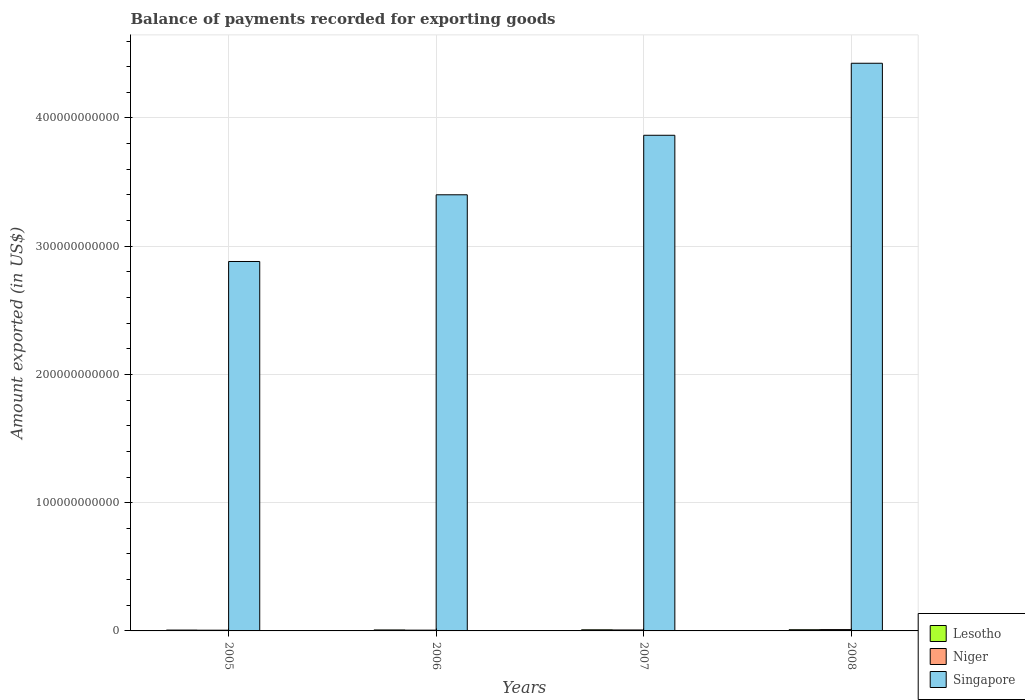Are the number of bars per tick equal to the number of legend labels?
Ensure brevity in your answer.  Yes. How many bars are there on the 1st tick from the left?
Ensure brevity in your answer.  3. In how many cases, is the number of bars for a given year not equal to the number of legend labels?
Offer a terse response. 0. What is the amount exported in Singapore in 2005?
Provide a short and direct response. 2.88e+11. Across all years, what is the maximum amount exported in Singapore?
Your response must be concise. 4.43e+11. Across all years, what is the minimum amount exported in Niger?
Your response must be concise. 5.65e+08. In which year was the amount exported in Niger minimum?
Your answer should be very brief. 2005. What is the total amount exported in Singapore in the graph?
Offer a very short reply. 1.46e+12. What is the difference between the amount exported in Niger in 2005 and that in 2008?
Your answer should be very brief. -4.78e+08. What is the difference between the amount exported in Lesotho in 2007 and the amount exported in Singapore in 2008?
Offer a terse response. -4.42e+11. What is the average amount exported in Singapore per year?
Offer a terse response. 3.64e+11. In the year 2005, what is the difference between the amount exported in Niger and amount exported in Singapore?
Your response must be concise. -2.88e+11. In how many years, is the amount exported in Lesotho greater than 200000000000 US$?
Make the answer very short. 0. What is the ratio of the amount exported in Lesotho in 2006 to that in 2008?
Give a very brief answer. 0.81. Is the difference between the amount exported in Niger in 2006 and 2008 greater than the difference between the amount exported in Singapore in 2006 and 2008?
Make the answer very short. Yes. What is the difference between the highest and the second highest amount exported in Niger?
Provide a short and direct response. 2.96e+08. What is the difference between the highest and the lowest amount exported in Lesotho?
Keep it short and to the point. 2.64e+08. Is the sum of the amount exported in Singapore in 2006 and 2008 greater than the maximum amount exported in Niger across all years?
Your answer should be very brief. Yes. What does the 2nd bar from the left in 2007 represents?
Offer a terse response. Niger. What does the 2nd bar from the right in 2007 represents?
Your answer should be compact. Niger. Is it the case that in every year, the sum of the amount exported in Niger and amount exported in Lesotho is greater than the amount exported in Singapore?
Your answer should be compact. No. Are all the bars in the graph horizontal?
Your answer should be compact. No. How many years are there in the graph?
Your answer should be very brief. 4. What is the difference between two consecutive major ticks on the Y-axis?
Your response must be concise. 1.00e+11. Does the graph contain any zero values?
Keep it short and to the point. No. Does the graph contain grids?
Provide a succinct answer. Yes. Where does the legend appear in the graph?
Provide a succinct answer. Bottom right. How many legend labels are there?
Your answer should be compact. 3. What is the title of the graph?
Offer a terse response. Balance of payments recorded for exporting goods. What is the label or title of the Y-axis?
Your response must be concise. Amount exported (in US$). What is the Amount exported (in US$) in Lesotho in 2005?
Offer a very short reply. 6.68e+08. What is the Amount exported (in US$) in Niger in 2005?
Provide a succinct answer. 5.65e+08. What is the Amount exported (in US$) of Singapore in 2005?
Offer a very short reply. 2.88e+11. What is the Amount exported (in US$) of Lesotho in 2006?
Keep it short and to the point. 7.57e+08. What is the Amount exported (in US$) of Niger in 2006?
Keep it short and to the point. 5.99e+08. What is the Amount exported (in US$) in Singapore in 2006?
Keep it short and to the point. 3.40e+11. What is the Amount exported (in US$) in Lesotho in 2007?
Offer a very short reply. 8.72e+08. What is the Amount exported (in US$) in Niger in 2007?
Your answer should be very brief. 7.47e+08. What is the Amount exported (in US$) in Singapore in 2007?
Provide a short and direct response. 3.86e+11. What is the Amount exported (in US$) of Lesotho in 2008?
Your response must be concise. 9.32e+08. What is the Amount exported (in US$) of Niger in 2008?
Ensure brevity in your answer.  1.04e+09. What is the Amount exported (in US$) in Singapore in 2008?
Offer a very short reply. 4.43e+11. Across all years, what is the maximum Amount exported (in US$) in Lesotho?
Make the answer very short. 9.32e+08. Across all years, what is the maximum Amount exported (in US$) in Niger?
Offer a very short reply. 1.04e+09. Across all years, what is the maximum Amount exported (in US$) in Singapore?
Offer a very short reply. 4.43e+11. Across all years, what is the minimum Amount exported (in US$) in Lesotho?
Your answer should be very brief. 6.68e+08. Across all years, what is the minimum Amount exported (in US$) of Niger?
Provide a succinct answer. 5.65e+08. Across all years, what is the minimum Amount exported (in US$) in Singapore?
Keep it short and to the point. 2.88e+11. What is the total Amount exported (in US$) of Lesotho in the graph?
Ensure brevity in your answer.  3.23e+09. What is the total Amount exported (in US$) of Niger in the graph?
Ensure brevity in your answer.  2.95e+09. What is the total Amount exported (in US$) of Singapore in the graph?
Offer a terse response. 1.46e+12. What is the difference between the Amount exported (in US$) in Lesotho in 2005 and that in 2006?
Give a very brief answer. -8.89e+07. What is the difference between the Amount exported (in US$) in Niger in 2005 and that in 2006?
Offer a terse response. -3.34e+07. What is the difference between the Amount exported (in US$) in Singapore in 2005 and that in 2006?
Your answer should be compact. -5.20e+1. What is the difference between the Amount exported (in US$) of Lesotho in 2005 and that in 2007?
Provide a short and direct response. -2.04e+08. What is the difference between the Amount exported (in US$) in Niger in 2005 and that in 2007?
Your response must be concise. -1.82e+08. What is the difference between the Amount exported (in US$) of Singapore in 2005 and that in 2007?
Make the answer very short. -9.84e+1. What is the difference between the Amount exported (in US$) in Lesotho in 2005 and that in 2008?
Your answer should be compact. -2.64e+08. What is the difference between the Amount exported (in US$) of Niger in 2005 and that in 2008?
Offer a terse response. -4.78e+08. What is the difference between the Amount exported (in US$) in Singapore in 2005 and that in 2008?
Keep it short and to the point. -1.55e+11. What is the difference between the Amount exported (in US$) of Lesotho in 2006 and that in 2007?
Your answer should be very brief. -1.15e+08. What is the difference between the Amount exported (in US$) of Niger in 2006 and that in 2007?
Provide a succinct answer. -1.49e+08. What is the difference between the Amount exported (in US$) of Singapore in 2006 and that in 2007?
Give a very brief answer. -4.64e+1. What is the difference between the Amount exported (in US$) of Lesotho in 2006 and that in 2008?
Offer a terse response. -1.75e+08. What is the difference between the Amount exported (in US$) of Niger in 2006 and that in 2008?
Your response must be concise. -4.45e+08. What is the difference between the Amount exported (in US$) of Singapore in 2006 and that in 2008?
Offer a terse response. -1.03e+11. What is the difference between the Amount exported (in US$) of Lesotho in 2007 and that in 2008?
Give a very brief answer. -6.01e+07. What is the difference between the Amount exported (in US$) in Niger in 2007 and that in 2008?
Your answer should be very brief. -2.96e+08. What is the difference between the Amount exported (in US$) in Singapore in 2007 and that in 2008?
Provide a short and direct response. -5.62e+1. What is the difference between the Amount exported (in US$) in Lesotho in 2005 and the Amount exported (in US$) in Niger in 2006?
Offer a very short reply. 6.96e+07. What is the difference between the Amount exported (in US$) of Lesotho in 2005 and the Amount exported (in US$) of Singapore in 2006?
Make the answer very short. -3.39e+11. What is the difference between the Amount exported (in US$) in Niger in 2005 and the Amount exported (in US$) in Singapore in 2006?
Offer a very short reply. -3.40e+11. What is the difference between the Amount exported (in US$) of Lesotho in 2005 and the Amount exported (in US$) of Niger in 2007?
Your answer should be very brief. -7.91e+07. What is the difference between the Amount exported (in US$) in Lesotho in 2005 and the Amount exported (in US$) in Singapore in 2007?
Your response must be concise. -3.86e+11. What is the difference between the Amount exported (in US$) in Niger in 2005 and the Amount exported (in US$) in Singapore in 2007?
Your response must be concise. -3.86e+11. What is the difference between the Amount exported (in US$) of Lesotho in 2005 and the Amount exported (in US$) of Niger in 2008?
Offer a very short reply. -3.75e+08. What is the difference between the Amount exported (in US$) in Lesotho in 2005 and the Amount exported (in US$) in Singapore in 2008?
Offer a very short reply. -4.42e+11. What is the difference between the Amount exported (in US$) of Niger in 2005 and the Amount exported (in US$) of Singapore in 2008?
Your answer should be compact. -4.42e+11. What is the difference between the Amount exported (in US$) in Lesotho in 2006 and the Amount exported (in US$) in Niger in 2007?
Your response must be concise. 9.83e+06. What is the difference between the Amount exported (in US$) in Lesotho in 2006 and the Amount exported (in US$) in Singapore in 2007?
Offer a terse response. -3.86e+11. What is the difference between the Amount exported (in US$) of Niger in 2006 and the Amount exported (in US$) of Singapore in 2007?
Keep it short and to the point. -3.86e+11. What is the difference between the Amount exported (in US$) of Lesotho in 2006 and the Amount exported (in US$) of Niger in 2008?
Provide a short and direct response. -2.86e+08. What is the difference between the Amount exported (in US$) of Lesotho in 2006 and the Amount exported (in US$) of Singapore in 2008?
Offer a very short reply. -4.42e+11. What is the difference between the Amount exported (in US$) of Niger in 2006 and the Amount exported (in US$) of Singapore in 2008?
Give a very brief answer. -4.42e+11. What is the difference between the Amount exported (in US$) in Lesotho in 2007 and the Amount exported (in US$) in Niger in 2008?
Keep it short and to the point. -1.71e+08. What is the difference between the Amount exported (in US$) in Lesotho in 2007 and the Amount exported (in US$) in Singapore in 2008?
Give a very brief answer. -4.42e+11. What is the difference between the Amount exported (in US$) in Niger in 2007 and the Amount exported (in US$) in Singapore in 2008?
Your answer should be very brief. -4.42e+11. What is the average Amount exported (in US$) in Lesotho per year?
Offer a terse response. 8.07e+08. What is the average Amount exported (in US$) of Niger per year?
Your answer should be compact. 7.38e+08. What is the average Amount exported (in US$) in Singapore per year?
Offer a terse response. 3.64e+11. In the year 2005, what is the difference between the Amount exported (in US$) of Lesotho and Amount exported (in US$) of Niger?
Keep it short and to the point. 1.03e+08. In the year 2005, what is the difference between the Amount exported (in US$) of Lesotho and Amount exported (in US$) of Singapore?
Your answer should be compact. -2.87e+11. In the year 2005, what is the difference between the Amount exported (in US$) in Niger and Amount exported (in US$) in Singapore?
Your response must be concise. -2.88e+11. In the year 2006, what is the difference between the Amount exported (in US$) in Lesotho and Amount exported (in US$) in Niger?
Provide a succinct answer. 1.58e+08. In the year 2006, what is the difference between the Amount exported (in US$) in Lesotho and Amount exported (in US$) in Singapore?
Give a very brief answer. -3.39e+11. In the year 2006, what is the difference between the Amount exported (in US$) in Niger and Amount exported (in US$) in Singapore?
Offer a terse response. -3.39e+11. In the year 2007, what is the difference between the Amount exported (in US$) of Lesotho and Amount exported (in US$) of Niger?
Ensure brevity in your answer.  1.25e+08. In the year 2007, what is the difference between the Amount exported (in US$) of Lesotho and Amount exported (in US$) of Singapore?
Offer a terse response. -3.86e+11. In the year 2007, what is the difference between the Amount exported (in US$) of Niger and Amount exported (in US$) of Singapore?
Provide a short and direct response. -3.86e+11. In the year 2008, what is the difference between the Amount exported (in US$) of Lesotho and Amount exported (in US$) of Niger?
Offer a terse response. -1.11e+08. In the year 2008, what is the difference between the Amount exported (in US$) of Lesotho and Amount exported (in US$) of Singapore?
Offer a terse response. -4.42e+11. In the year 2008, what is the difference between the Amount exported (in US$) in Niger and Amount exported (in US$) in Singapore?
Ensure brevity in your answer.  -4.42e+11. What is the ratio of the Amount exported (in US$) in Lesotho in 2005 to that in 2006?
Your response must be concise. 0.88. What is the ratio of the Amount exported (in US$) in Niger in 2005 to that in 2006?
Give a very brief answer. 0.94. What is the ratio of the Amount exported (in US$) of Singapore in 2005 to that in 2006?
Offer a very short reply. 0.85. What is the ratio of the Amount exported (in US$) of Lesotho in 2005 to that in 2007?
Provide a short and direct response. 0.77. What is the ratio of the Amount exported (in US$) in Niger in 2005 to that in 2007?
Offer a very short reply. 0.76. What is the ratio of the Amount exported (in US$) in Singapore in 2005 to that in 2007?
Ensure brevity in your answer.  0.75. What is the ratio of the Amount exported (in US$) in Lesotho in 2005 to that in 2008?
Give a very brief answer. 0.72. What is the ratio of the Amount exported (in US$) in Niger in 2005 to that in 2008?
Offer a terse response. 0.54. What is the ratio of the Amount exported (in US$) in Singapore in 2005 to that in 2008?
Ensure brevity in your answer.  0.65. What is the ratio of the Amount exported (in US$) of Lesotho in 2006 to that in 2007?
Make the answer very short. 0.87. What is the ratio of the Amount exported (in US$) in Niger in 2006 to that in 2007?
Provide a short and direct response. 0.8. What is the ratio of the Amount exported (in US$) of Singapore in 2006 to that in 2007?
Ensure brevity in your answer.  0.88. What is the ratio of the Amount exported (in US$) in Lesotho in 2006 to that in 2008?
Keep it short and to the point. 0.81. What is the ratio of the Amount exported (in US$) in Niger in 2006 to that in 2008?
Give a very brief answer. 0.57. What is the ratio of the Amount exported (in US$) of Singapore in 2006 to that in 2008?
Make the answer very short. 0.77. What is the ratio of the Amount exported (in US$) of Lesotho in 2007 to that in 2008?
Give a very brief answer. 0.94. What is the ratio of the Amount exported (in US$) of Niger in 2007 to that in 2008?
Make the answer very short. 0.72. What is the ratio of the Amount exported (in US$) in Singapore in 2007 to that in 2008?
Provide a short and direct response. 0.87. What is the difference between the highest and the second highest Amount exported (in US$) in Lesotho?
Offer a very short reply. 6.01e+07. What is the difference between the highest and the second highest Amount exported (in US$) in Niger?
Your answer should be very brief. 2.96e+08. What is the difference between the highest and the second highest Amount exported (in US$) of Singapore?
Your response must be concise. 5.62e+1. What is the difference between the highest and the lowest Amount exported (in US$) of Lesotho?
Keep it short and to the point. 2.64e+08. What is the difference between the highest and the lowest Amount exported (in US$) in Niger?
Offer a very short reply. 4.78e+08. What is the difference between the highest and the lowest Amount exported (in US$) of Singapore?
Provide a succinct answer. 1.55e+11. 